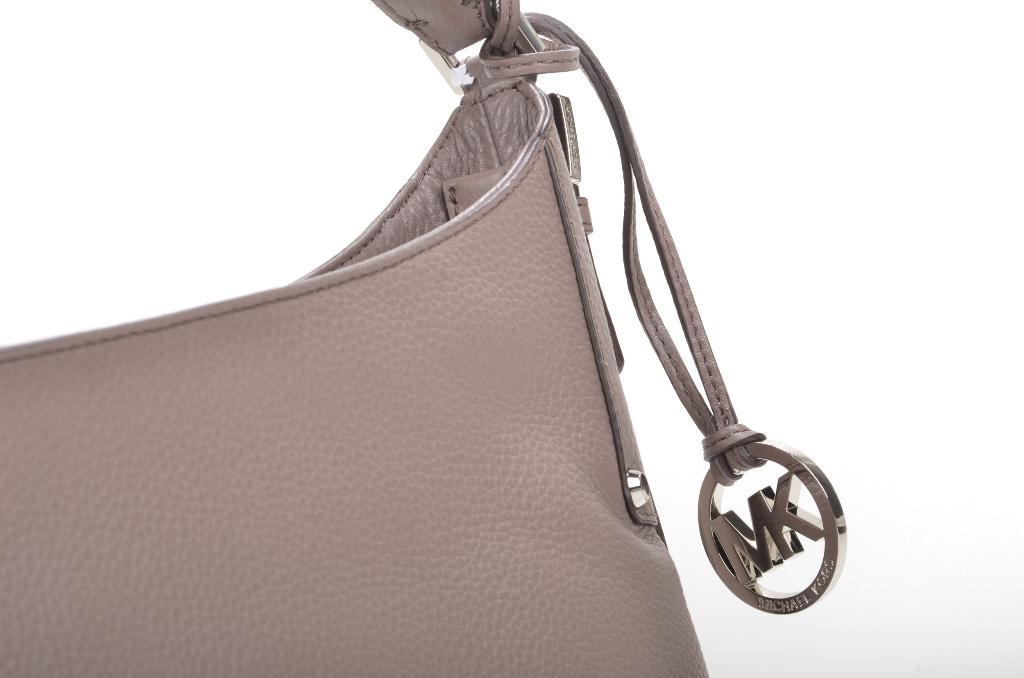What object in the image appears to be cut off or incomplete? There is a bag in the image that is truncated. What type of brush is used to paint the country in the image? There is no brush, country, or painting present in the image. 